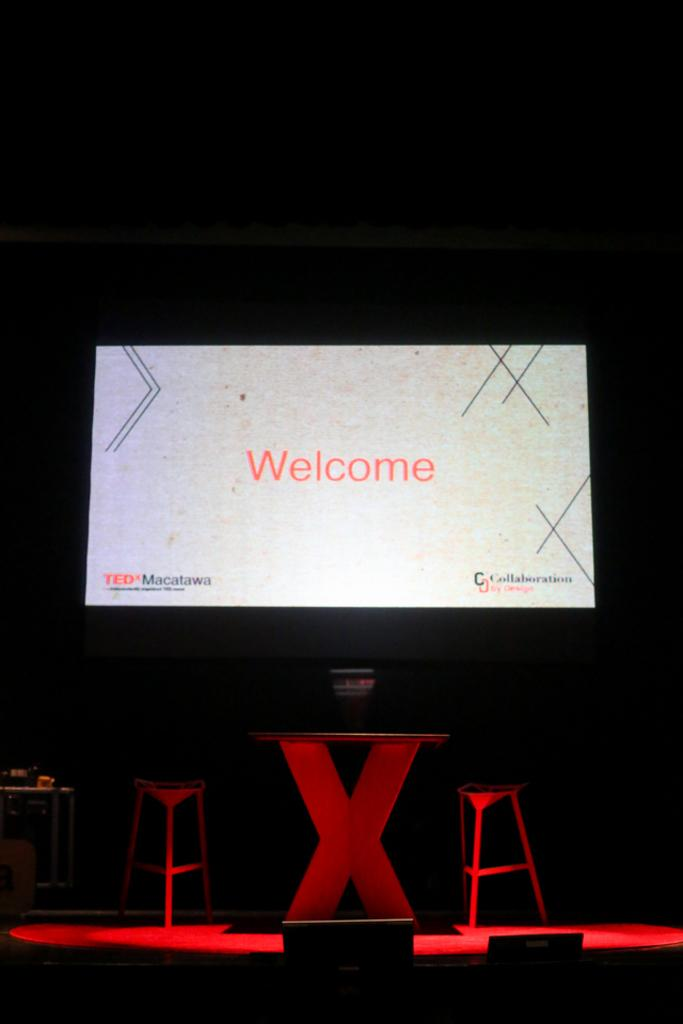<image>
Create a compact narrative representing the image presented. The start of a Ted Talk begins on a dim stage. 